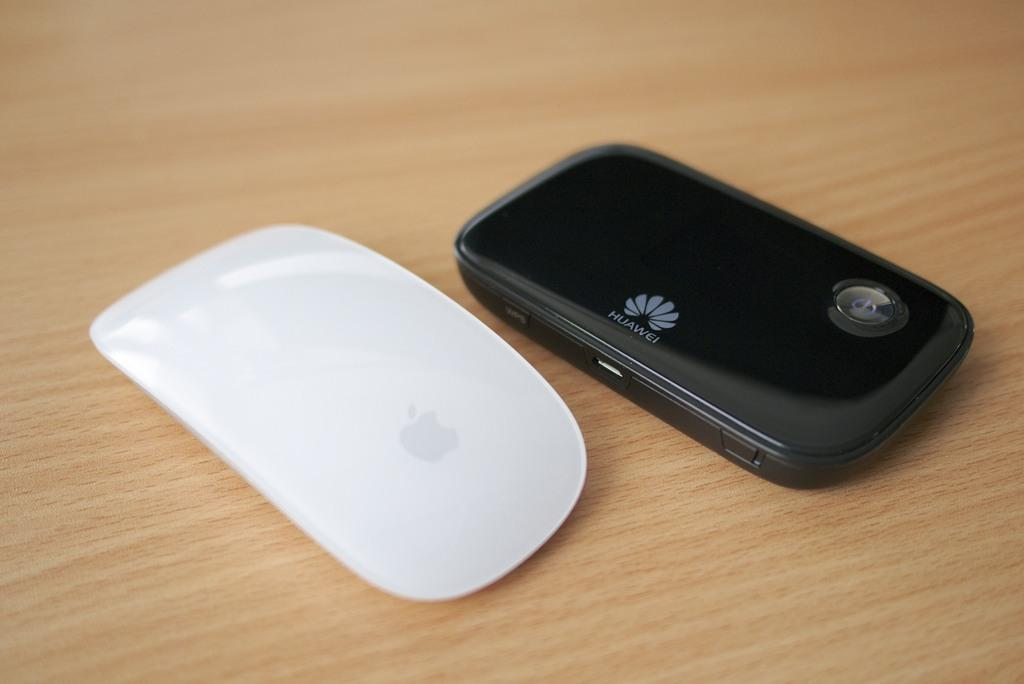<image>
Create a compact narrative representing the image presented. a Huawei cell phone that is black next to a white mouse 